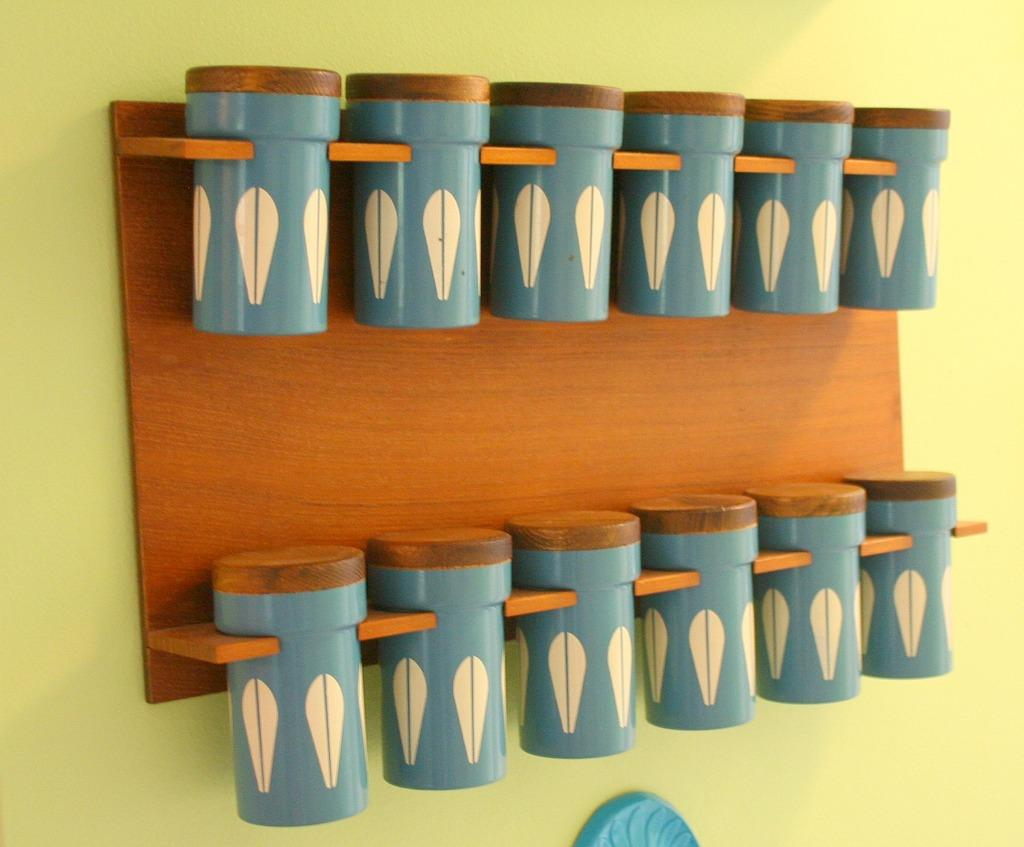What objects are present in the image? There are boxes in the image. How are the boxes positioned in the image? The boxes are attached to a wall. What color are the boxes? The boxes are blue in color. What type of wool is being used to create the page in the image? There is no page or wool present in the image; it only features blue boxes attached to a wall. 